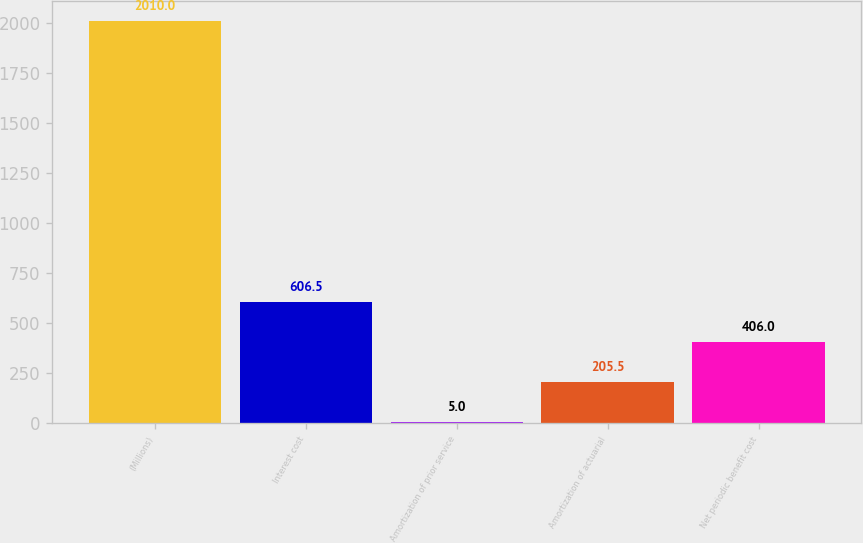Convert chart. <chart><loc_0><loc_0><loc_500><loc_500><bar_chart><fcel>(Millions)<fcel>Interest cost<fcel>Amortization of prior service<fcel>Amortization of actuarial<fcel>Net periodic benefit cost<nl><fcel>2010<fcel>606.5<fcel>5<fcel>205.5<fcel>406<nl></chart> 